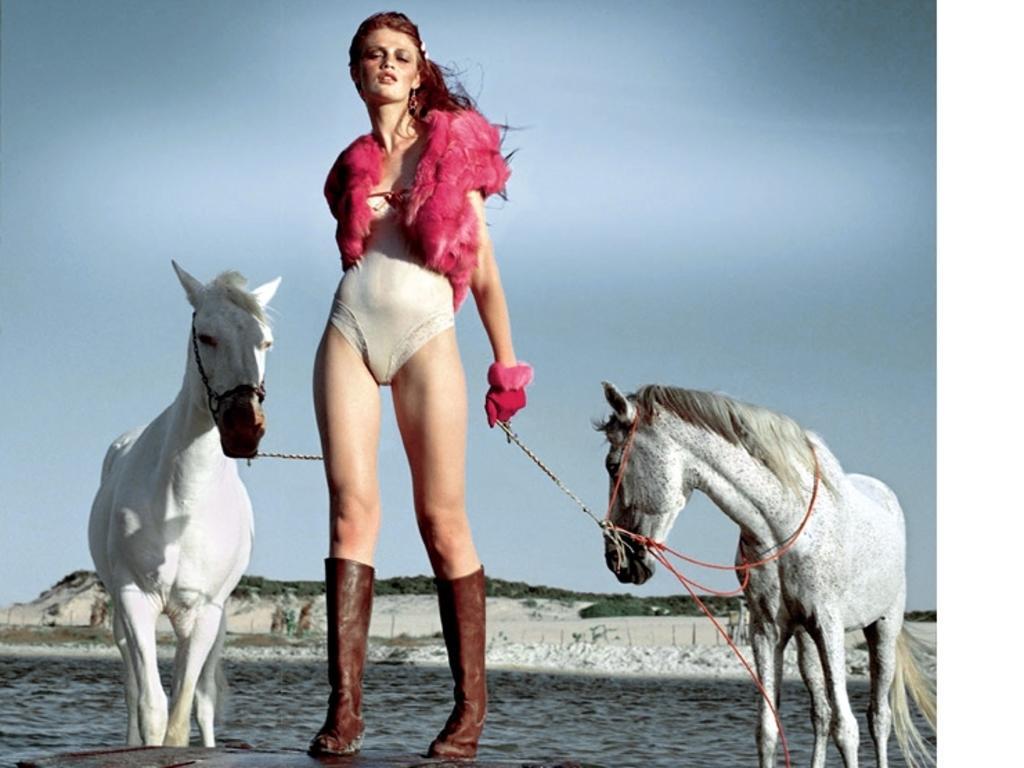Describe this image in one or two sentences. This image is taken in outdoors. In the middle of the image a girl is standing wearing boots and shrug. In the right side of the image there is a horse tied with rope. In the left side of the image a horse is standing. At the bottom of the image there is a water. At the background there is a sky and a mountains. 